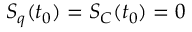Convert formula to latex. <formula><loc_0><loc_0><loc_500><loc_500>S _ { q } ( t _ { 0 } ) = S _ { C } ( t _ { 0 } ) = 0</formula> 